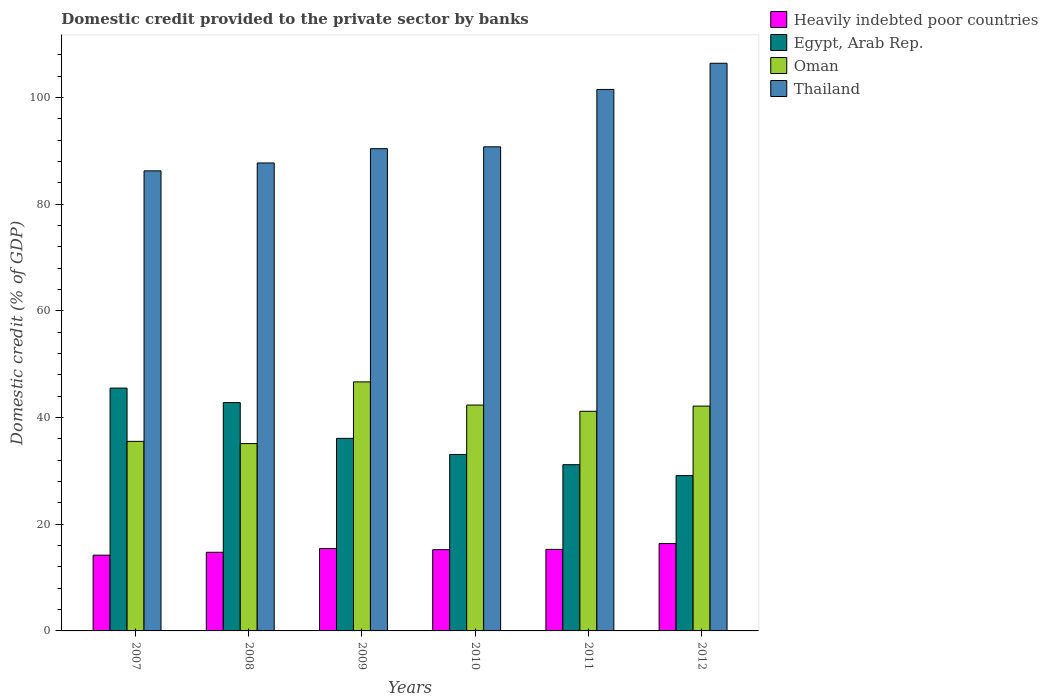How many different coloured bars are there?
Offer a very short reply. 4. How many bars are there on the 6th tick from the left?
Keep it short and to the point. 4. How many bars are there on the 6th tick from the right?
Keep it short and to the point. 4. What is the domestic credit provided to the private sector by banks in Oman in 2007?
Give a very brief answer. 35.53. Across all years, what is the maximum domestic credit provided to the private sector by banks in Thailand?
Provide a short and direct response. 106.4. Across all years, what is the minimum domestic credit provided to the private sector by banks in Thailand?
Offer a very short reply. 86.23. In which year was the domestic credit provided to the private sector by banks in Thailand maximum?
Provide a succinct answer. 2012. In which year was the domestic credit provided to the private sector by banks in Egypt, Arab Rep. minimum?
Provide a short and direct response. 2012. What is the total domestic credit provided to the private sector by banks in Oman in the graph?
Provide a succinct answer. 242.95. What is the difference between the domestic credit provided to the private sector by banks in Egypt, Arab Rep. in 2009 and that in 2012?
Make the answer very short. 6.98. What is the difference between the domestic credit provided to the private sector by banks in Egypt, Arab Rep. in 2009 and the domestic credit provided to the private sector by banks in Heavily indebted poor countries in 2012?
Ensure brevity in your answer.  19.72. What is the average domestic credit provided to the private sector by banks in Thailand per year?
Keep it short and to the point. 93.82. In the year 2010, what is the difference between the domestic credit provided to the private sector by banks in Egypt, Arab Rep. and domestic credit provided to the private sector by banks in Thailand?
Keep it short and to the point. -57.66. In how many years, is the domestic credit provided to the private sector by banks in Egypt, Arab Rep. greater than 40 %?
Ensure brevity in your answer.  2. What is the ratio of the domestic credit provided to the private sector by banks in Thailand in 2009 to that in 2011?
Make the answer very short. 0.89. Is the domestic credit provided to the private sector by banks in Oman in 2008 less than that in 2012?
Ensure brevity in your answer.  Yes. Is the difference between the domestic credit provided to the private sector by banks in Egypt, Arab Rep. in 2007 and 2012 greater than the difference between the domestic credit provided to the private sector by banks in Thailand in 2007 and 2012?
Your response must be concise. Yes. What is the difference between the highest and the second highest domestic credit provided to the private sector by banks in Egypt, Arab Rep.?
Offer a terse response. 2.72. What is the difference between the highest and the lowest domestic credit provided to the private sector by banks in Oman?
Give a very brief answer. 11.57. In how many years, is the domestic credit provided to the private sector by banks in Egypt, Arab Rep. greater than the average domestic credit provided to the private sector by banks in Egypt, Arab Rep. taken over all years?
Ensure brevity in your answer.  2. Is the sum of the domestic credit provided to the private sector by banks in Thailand in 2009 and 2012 greater than the maximum domestic credit provided to the private sector by banks in Egypt, Arab Rep. across all years?
Make the answer very short. Yes. Is it the case that in every year, the sum of the domestic credit provided to the private sector by banks in Thailand and domestic credit provided to the private sector by banks in Oman is greater than the sum of domestic credit provided to the private sector by banks in Heavily indebted poor countries and domestic credit provided to the private sector by banks in Egypt, Arab Rep.?
Make the answer very short. No. What does the 3rd bar from the left in 2012 represents?
Your answer should be very brief. Oman. What does the 4th bar from the right in 2012 represents?
Offer a terse response. Heavily indebted poor countries. Is it the case that in every year, the sum of the domestic credit provided to the private sector by banks in Egypt, Arab Rep. and domestic credit provided to the private sector by banks in Heavily indebted poor countries is greater than the domestic credit provided to the private sector by banks in Oman?
Give a very brief answer. Yes. Are all the bars in the graph horizontal?
Keep it short and to the point. No. How many years are there in the graph?
Keep it short and to the point. 6. Are the values on the major ticks of Y-axis written in scientific E-notation?
Ensure brevity in your answer.  No. Does the graph contain any zero values?
Provide a succinct answer. No. What is the title of the graph?
Provide a succinct answer. Domestic credit provided to the private sector by banks. What is the label or title of the Y-axis?
Provide a succinct answer. Domestic credit (% of GDP). What is the Domestic credit (% of GDP) of Heavily indebted poor countries in 2007?
Ensure brevity in your answer.  14.19. What is the Domestic credit (% of GDP) of Egypt, Arab Rep. in 2007?
Keep it short and to the point. 45.52. What is the Domestic credit (% of GDP) of Oman in 2007?
Keep it short and to the point. 35.53. What is the Domestic credit (% of GDP) in Thailand in 2007?
Provide a succinct answer. 86.23. What is the Domestic credit (% of GDP) in Heavily indebted poor countries in 2008?
Offer a very short reply. 14.74. What is the Domestic credit (% of GDP) of Egypt, Arab Rep. in 2008?
Offer a very short reply. 42.8. What is the Domestic credit (% of GDP) in Oman in 2008?
Provide a succinct answer. 35.11. What is the Domestic credit (% of GDP) of Thailand in 2008?
Your answer should be very brief. 87.71. What is the Domestic credit (% of GDP) in Heavily indebted poor countries in 2009?
Provide a short and direct response. 15.44. What is the Domestic credit (% of GDP) in Egypt, Arab Rep. in 2009?
Your response must be concise. 36.09. What is the Domestic credit (% of GDP) in Oman in 2009?
Your answer should be compact. 46.68. What is the Domestic credit (% of GDP) of Thailand in 2009?
Your response must be concise. 90.38. What is the Domestic credit (% of GDP) of Heavily indebted poor countries in 2010?
Offer a terse response. 15.23. What is the Domestic credit (% of GDP) in Egypt, Arab Rep. in 2010?
Ensure brevity in your answer.  33.07. What is the Domestic credit (% of GDP) of Oman in 2010?
Make the answer very short. 42.33. What is the Domestic credit (% of GDP) of Thailand in 2010?
Your answer should be very brief. 90.73. What is the Domestic credit (% of GDP) in Heavily indebted poor countries in 2011?
Make the answer very short. 15.28. What is the Domestic credit (% of GDP) in Egypt, Arab Rep. in 2011?
Offer a very short reply. 31.15. What is the Domestic credit (% of GDP) of Oman in 2011?
Offer a very short reply. 41.17. What is the Domestic credit (% of GDP) of Thailand in 2011?
Make the answer very short. 101.49. What is the Domestic credit (% of GDP) of Heavily indebted poor countries in 2012?
Your response must be concise. 16.37. What is the Domestic credit (% of GDP) in Egypt, Arab Rep. in 2012?
Provide a short and direct response. 29.11. What is the Domestic credit (% of GDP) of Oman in 2012?
Your answer should be very brief. 42.14. What is the Domestic credit (% of GDP) of Thailand in 2012?
Ensure brevity in your answer.  106.4. Across all years, what is the maximum Domestic credit (% of GDP) in Heavily indebted poor countries?
Your answer should be very brief. 16.37. Across all years, what is the maximum Domestic credit (% of GDP) in Egypt, Arab Rep.?
Provide a succinct answer. 45.52. Across all years, what is the maximum Domestic credit (% of GDP) in Oman?
Provide a succinct answer. 46.68. Across all years, what is the maximum Domestic credit (% of GDP) of Thailand?
Keep it short and to the point. 106.4. Across all years, what is the minimum Domestic credit (% of GDP) of Heavily indebted poor countries?
Ensure brevity in your answer.  14.19. Across all years, what is the minimum Domestic credit (% of GDP) of Egypt, Arab Rep.?
Provide a short and direct response. 29.11. Across all years, what is the minimum Domestic credit (% of GDP) of Oman?
Your answer should be very brief. 35.11. Across all years, what is the minimum Domestic credit (% of GDP) in Thailand?
Your answer should be very brief. 86.23. What is the total Domestic credit (% of GDP) of Heavily indebted poor countries in the graph?
Provide a short and direct response. 91.26. What is the total Domestic credit (% of GDP) of Egypt, Arab Rep. in the graph?
Give a very brief answer. 217.75. What is the total Domestic credit (% of GDP) in Oman in the graph?
Make the answer very short. 242.95. What is the total Domestic credit (% of GDP) of Thailand in the graph?
Provide a short and direct response. 562.93. What is the difference between the Domestic credit (% of GDP) in Heavily indebted poor countries in 2007 and that in 2008?
Offer a very short reply. -0.55. What is the difference between the Domestic credit (% of GDP) of Egypt, Arab Rep. in 2007 and that in 2008?
Offer a terse response. 2.72. What is the difference between the Domestic credit (% of GDP) of Oman in 2007 and that in 2008?
Offer a very short reply. 0.42. What is the difference between the Domestic credit (% of GDP) in Thailand in 2007 and that in 2008?
Your answer should be very brief. -1.48. What is the difference between the Domestic credit (% of GDP) of Heavily indebted poor countries in 2007 and that in 2009?
Offer a terse response. -1.25. What is the difference between the Domestic credit (% of GDP) of Egypt, Arab Rep. in 2007 and that in 2009?
Your answer should be compact. 9.42. What is the difference between the Domestic credit (% of GDP) of Oman in 2007 and that in 2009?
Your answer should be very brief. -11.15. What is the difference between the Domestic credit (% of GDP) in Thailand in 2007 and that in 2009?
Offer a terse response. -4.16. What is the difference between the Domestic credit (% of GDP) in Heavily indebted poor countries in 2007 and that in 2010?
Your answer should be very brief. -1.03. What is the difference between the Domestic credit (% of GDP) in Egypt, Arab Rep. in 2007 and that in 2010?
Give a very brief answer. 12.44. What is the difference between the Domestic credit (% of GDP) of Oman in 2007 and that in 2010?
Provide a succinct answer. -6.81. What is the difference between the Domestic credit (% of GDP) in Thailand in 2007 and that in 2010?
Offer a very short reply. -4.5. What is the difference between the Domestic credit (% of GDP) in Heavily indebted poor countries in 2007 and that in 2011?
Your answer should be compact. -1.09. What is the difference between the Domestic credit (% of GDP) of Egypt, Arab Rep. in 2007 and that in 2011?
Keep it short and to the point. 14.36. What is the difference between the Domestic credit (% of GDP) of Oman in 2007 and that in 2011?
Make the answer very short. -5.64. What is the difference between the Domestic credit (% of GDP) of Thailand in 2007 and that in 2011?
Give a very brief answer. -15.26. What is the difference between the Domestic credit (% of GDP) in Heavily indebted poor countries in 2007 and that in 2012?
Provide a short and direct response. -2.18. What is the difference between the Domestic credit (% of GDP) of Egypt, Arab Rep. in 2007 and that in 2012?
Provide a succinct answer. 16.4. What is the difference between the Domestic credit (% of GDP) of Oman in 2007 and that in 2012?
Offer a terse response. -6.61. What is the difference between the Domestic credit (% of GDP) in Thailand in 2007 and that in 2012?
Keep it short and to the point. -20.17. What is the difference between the Domestic credit (% of GDP) of Heavily indebted poor countries in 2008 and that in 2009?
Provide a succinct answer. -0.7. What is the difference between the Domestic credit (% of GDP) of Egypt, Arab Rep. in 2008 and that in 2009?
Provide a short and direct response. 6.7. What is the difference between the Domestic credit (% of GDP) in Oman in 2008 and that in 2009?
Give a very brief answer. -11.57. What is the difference between the Domestic credit (% of GDP) in Thailand in 2008 and that in 2009?
Provide a short and direct response. -2.68. What is the difference between the Domestic credit (% of GDP) of Heavily indebted poor countries in 2008 and that in 2010?
Offer a very short reply. -0.48. What is the difference between the Domestic credit (% of GDP) in Egypt, Arab Rep. in 2008 and that in 2010?
Offer a very short reply. 9.73. What is the difference between the Domestic credit (% of GDP) in Oman in 2008 and that in 2010?
Keep it short and to the point. -7.23. What is the difference between the Domestic credit (% of GDP) in Thailand in 2008 and that in 2010?
Make the answer very short. -3.02. What is the difference between the Domestic credit (% of GDP) in Heavily indebted poor countries in 2008 and that in 2011?
Keep it short and to the point. -0.54. What is the difference between the Domestic credit (% of GDP) of Egypt, Arab Rep. in 2008 and that in 2011?
Your answer should be compact. 11.64. What is the difference between the Domestic credit (% of GDP) of Oman in 2008 and that in 2011?
Offer a very short reply. -6.06. What is the difference between the Domestic credit (% of GDP) in Thailand in 2008 and that in 2011?
Provide a succinct answer. -13.78. What is the difference between the Domestic credit (% of GDP) in Heavily indebted poor countries in 2008 and that in 2012?
Make the answer very short. -1.63. What is the difference between the Domestic credit (% of GDP) of Egypt, Arab Rep. in 2008 and that in 2012?
Offer a terse response. 13.68. What is the difference between the Domestic credit (% of GDP) of Oman in 2008 and that in 2012?
Offer a very short reply. -7.03. What is the difference between the Domestic credit (% of GDP) in Thailand in 2008 and that in 2012?
Your answer should be very brief. -18.69. What is the difference between the Domestic credit (% of GDP) of Heavily indebted poor countries in 2009 and that in 2010?
Your response must be concise. 0.22. What is the difference between the Domestic credit (% of GDP) of Egypt, Arab Rep. in 2009 and that in 2010?
Your answer should be very brief. 3.02. What is the difference between the Domestic credit (% of GDP) in Oman in 2009 and that in 2010?
Ensure brevity in your answer.  4.34. What is the difference between the Domestic credit (% of GDP) of Thailand in 2009 and that in 2010?
Provide a short and direct response. -0.35. What is the difference between the Domestic credit (% of GDP) of Heavily indebted poor countries in 2009 and that in 2011?
Ensure brevity in your answer.  0.16. What is the difference between the Domestic credit (% of GDP) of Egypt, Arab Rep. in 2009 and that in 2011?
Make the answer very short. 4.94. What is the difference between the Domestic credit (% of GDP) of Oman in 2009 and that in 2011?
Keep it short and to the point. 5.51. What is the difference between the Domestic credit (% of GDP) in Thailand in 2009 and that in 2011?
Your response must be concise. -11.1. What is the difference between the Domestic credit (% of GDP) in Heavily indebted poor countries in 2009 and that in 2012?
Your response must be concise. -0.93. What is the difference between the Domestic credit (% of GDP) of Egypt, Arab Rep. in 2009 and that in 2012?
Keep it short and to the point. 6.98. What is the difference between the Domestic credit (% of GDP) of Oman in 2009 and that in 2012?
Your answer should be compact. 4.54. What is the difference between the Domestic credit (% of GDP) in Thailand in 2009 and that in 2012?
Provide a succinct answer. -16.01. What is the difference between the Domestic credit (% of GDP) of Heavily indebted poor countries in 2010 and that in 2011?
Make the answer very short. -0.06. What is the difference between the Domestic credit (% of GDP) in Egypt, Arab Rep. in 2010 and that in 2011?
Provide a succinct answer. 1.92. What is the difference between the Domestic credit (% of GDP) of Oman in 2010 and that in 2011?
Make the answer very short. 1.17. What is the difference between the Domestic credit (% of GDP) in Thailand in 2010 and that in 2011?
Make the answer very short. -10.76. What is the difference between the Domestic credit (% of GDP) of Heavily indebted poor countries in 2010 and that in 2012?
Your answer should be very brief. -1.15. What is the difference between the Domestic credit (% of GDP) in Egypt, Arab Rep. in 2010 and that in 2012?
Ensure brevity in your answer.  3.96. What is the difference between the Domestic credit (% of GDP) in Oman in 2010 and that in 2012?
Ensure brevity in your answer.  0.19. What is the difference between the Domestic credit (% of GDP) in Thailand in 2010 and that in 2012?
Ensure brevity in your answer.  -15.66. What is the difference between the Domestic credit (% of GDP) of Heavily indebted poor countries in 2011 and that in 2012?
Offer a very short reply. -1.09. What is the difference between the Domestic credit (% of GDP) in Egypt, Arab Rep. in 2011 and that in 2012?
Offer a terse response. 2.04. What is the difference between the Domestic credit (% of GDP) in Oman in 2011 and that in 2012?
Make the answer very short. -0.97. What is the difference between the Domestic credit (% of GDP) in Thailand in 2011 and that in 2012?
Offer a very short reply. -4.91. What is the difference between the Domestic credit (% of GDP) of Heavily indebted poor countries in 2007 and the Domestic credit (% of GDP) of Egypt, Arab Rep. in 2008?
Keep it short and to the point. -28.6. What is the difference between the Domestic credit (% of GDP) in Heavily indebted poor countries in 2007 and the Domestic credit (% of GDP) in Oman in 2008?
Provide a succinct answer. -20.91. What is the difference between the Domestic credit (% of GDP) in Heavily indebted poor countries in 2007 and the Domestic credit (% of GDP) in Thailand in 2008?
Your answer should be compact. -73.51. What is the difference between the Domestic credit (% of GDP) of Egypt, Arab Rep. in 2007 and the Domestic credit (% of GDP) of Oman in 2008?
Provide a short and direct response. 10.41. What is the difference between the Domestic credit (% of GDP) in Egypt, Arab Rep. in 2007 and the Domestic credit (% of GDP) in Thailand in 2008?
Provide a short and direct response. -42.19. What is the difference between the Domestic credit (% of GDP) in Oman in 2007 and the Domestic credit (% of GDP) in Thailand in 2008?
Offer a terse response. -52.18. What is the difference between the Domestic credit (% of GDP) of Heavily indebted poor countries in 2007 and the Domestic credit (% of GDP) of Egypt, Arab Rep. in 2009?
Provide a succinct answer. -21.9. What is the difference between the Domestic credit (% of GDP) in Heavily indebted poor countries in 2007 and the Domestic credit (% of GDP) in Oman in 2009?
Provide a short and direct response. -32.48. What is the difference between the Domestic credit (% of GDP) in Heavily indebted poor countries in 2007 and the Domestic credit (% of GDP) in Thailand in 2009?
Ensure brevity in your answer.  -76.19. What is the difference between the Domestic credit (% of GDP) of Egypt, Arab Rep. in 2007 and the Domestic credit (% of GDP) of Oman in 2009?
Offer a terse response. -1.16. What is the difference between the Domestic credit (% of GDP) in Egypt, Arab Rep. in 2007 and the Domestic credit (% of GDP) in Thailand in 2009?
Make the answer very short. -44.87. What is the difference between the Domestic credit (% of GDP) of Oman in 2007 and the Domestic credit (% of GDP) of Thailand in 2009?
Give a very brief answer. -54.86. What is the difference between the Domestic credit (% of GDP) of Heavily indebted poor countries in 2007 and the Domestic credit (% of GDP) of Egypt, Arab Rep. in 2010?
Ensure brevity in your answer.  -18.88. What is the difference between the Domestic credit (% of GDP) of Heavily indebted poor countries in 2007 and the Domestic credit (% of GDP) of Oman in 2010?
Ensure brevity in your answer.  -28.14. What is the difference between the Domestic credit (% of GDP) of Heavily indebted poor countries in 2007 and the Domestic credit (% of GDP) of Thailand in 2010?
Give a very brief answer. -76.54. What is the difference between the Domestic credit (% of GDP) of Egypt, Arab Rep. in 2007 and the Domestic credit (% of GDP) of Oman in 2010?
Make the answer very short. 3.18. What is the difference between the Domestic credit (% of GDP) in Egypt, Arab Rep. in 2007 and the Domestic credit (% of GDP) in Thailand in 2010?
Provide a short and direct response. -45.22. What is the difference between the Domestic credit (% of GDP) of Oman in 2007 and the Domestic credit (% of GDP) of Thailand in 2010?
Make the answer very short. -55.2. What is the difference between the Domestic credit (% of GDP) in Heavily indebted poor countries in 2007 and the Domestic credit (% of GDP) in Egypt, Arab Rep. in 2011?
Keep it short and to the point. -16.96. What is the difference between the Domestic credit (% of GDP) of Heavily indebted poor countries in 2007 and the Domestic credit (% of GDP) of Oman in 2011?
Offer a very short reply. -26.97. What is the difference between the Domestic credit (% of GDP) of Heavily indebted poor countries in 2007 and the Domestic credit (% of GDP) of Thailand in 2011?
Give a very brief answer. -87.29. What is the difference between the Domestic credit (% of GDP) in Egypt, Arab Rep. in 2007 and the Domestic credit (% of GDP) in Oman in 2011?
Offer a terse response. 4.35. What is the difference between the Domestic credit (% of GDP) in Egypt, Arab Rep. in 2007 and the Domestic credit (% of GDP) in Thailand in 2011?
Your answer should be compact. -55.97. What is the difference between the Domestic credit (% of GDP) in Oman in 2007 and the Domestic credit (% of GDP) in Thailand in 2011?
Offer a very short reply. -65.96. What is the difference between the Domestic credit (% of GDP) of Heavily indebted poor countries in 2007 and the Domestic credit (% of GDP) of Egypt, Arab Rep. in 2012?
Your answer should be compact. -14.92. What is the difference between the Domestic credit (% of GDP) in Heavily indebted poor countries in 2007 and the Domestic credit (% of GDP) in Oman in 2012?
Give a very brief answer. -27.95. What is the difference between the Domestic credit (% of GDP) of Heavily indebted poor countries in 2007 and the Domestic credit (% of GDP) of Thailand in 2012?
Provide a short and direct response. -92.2. What is the difference between the Domestic credit (% of GDP) in Egypt, Arab Rep. in 2007 and the Domestic credit (% of GDP) in Oman in 2012?
Ensure brevity in your answer.  3.37. What is the difference between the Domestic credit (% of GDP) of Egypt, Arab Rep. in 2007 and the Domestic credit (% of GDP) of Thailand in 2012?
Keep it short and to the point. -60.88. What is the difference between the Domestic credit (% of GDP) of Oman in 2007 and the Domestic credit (% of GDP) of Thailand in 2012?
Provide a short and direct response. -70.87. What is the difference between the Domestic credit (% of GDP) in Heavily indebted poor countries in 2008 and the Domestic credit (% of GDP) in Egypt, Arab Rep. in 2009?
Your response must be concise. -21.35. What is the difference between the Domestic credit (% of GDP) of Heavily indebted poor countries in 2008 and the Domestic credit (% of GDP) of Oman in 2009?
Offer a terse response. -31.94. What is the difference between the Domestic credit (% of GDP) in Heavily indebted poor countries in 2008 and the Domestic credit (% of GDP) in Thailand in 2009?
Offer a very short reply. -75.64. What is the difference between the Domestic credit (% of GDP) in Egypt, Arab Rep. in 2008 and the Domestic credit (% of GDP) in Oman in 2009?
Offer a very short reply. -3.88. What is the difference between the Domestic credit (% of GDP) of Egypt, Arab Rep. in 2008 and the Domestic credit (% of GDP) of Thailand in 2009?
Give a very brief answer. -47.59. What is the difference between the Domestic credit (% of GDP) in Oman in 2008 and the Domestic credit (% of GDP) in Thailand in 2009?
Provide a short and direct response. -55.28. What is the difference between the Domestic credit (% of GDP) of Heavily indebted poor countries in 2008 and the Domestic credit (% of GDP) of Egypt, Arab Rep. in 2010?
Offer a very short reply. -18.33. What is the difference between the Domestic credit (% of GDP) in Heavily indebted poor countries in 2008 and the Domestic credit (% of GDP) in Oman in 2010?
Your answer should be compact. -27.59. What is the difference between the Domestic credit (% of GDP) in Heavily indebted poor countries in 2008 and the Domestic credit (% of GDP) in Thailand in 2010?
Ensure brevity in your answer.  -75.99. What is the difference between the Domestic credit (% of GDP) of Egypt, Arab Rep. in 2008 and the Domestic credit (% of GDP) of Oman in 2010?
Provide a short and direct response. 0.46. What is the difference between the Domestic credit (% of GDP) of Egypt, Arab Rep. in 2008 and the Domestic credit (% of GDP) of Thailand in 2010?
Your answer should be compact. -47.93. What is the difference between the Domestic credit (% of GDP) of Oman in 2008 and the Domestic credit (% of GDP) of Thailand in 2010?
Provide a short and direct response. -55.62. What is the difference between the Domestic credit (% of GDP) of Heavily indebted poor countries in 2008 and the Domestic credit (% of GDP) of Egypt, Arab Rep. in 2011?
Your answer should be compact. -16.41. What is the difference between the Domestic credit (% of GDP) of Heavily indebted poor countries in 2008 and the Domestic credit (% of GDP) of Oman in 2011?
Make the answer very short. -26.43. What is the difference between the Domestic credit (% of GDP) of Heavily indebted poor countries in 2008 and the Domestic credit (% of GDP) of Thailand in 2011?
Ensure brevity in your answer.  -86.75. What is the difference between the Domestic credit (% of GDP) of Egypt, Arab Rep. in 2008 and the Domestic credit (% of GDP) of Oman in 2011?
Offer a terse response. 1.63. What is the difference between the Domestic credit (% of GDP) in Egypt, Arab Rep. in 2008 and the Domestic credit (% of GDP) in Thailand in 2011?
Provide a succinct answer. -58.69. What is the difference between the Domestic credit (% of GDP) in Oman in 2008 and the Domestic credit (% of GDP) in Thailand in 2011?
Your answer should be very brief. -66.38. What is the difference between the Domestic credit (% of GDP) of Heavily indebted poor countries in 2008 and the Domestic credit (% of GDP) of Egypt, Arab Rep. in 2012?
Your answer should be very brief. -14.37. What is the difference between the Domestic credit (% of GDP) of Heavily indebted poor countries in 2008 and the Domestic credit (% of GDP) of Oman in 2012?
Your answer should be compact. -27.4. What is the difference between the Domestic credit (% of GDP) in Heavily indebted poor countries in 2008 and the Domestic credit (% of GDP) in Thailand in 2012?
Keep it short and to the point. -91.65. What is the difference between the Domestic credit (% of GDP) in Egypt, Arab Rep. in 2008 and the Domestic credit (% of GDP) in Oman in 2012?
Offer a terse response. 0.66. What is the difference between the Domestic credit (% of GDP) in Egypt, Arab Rep. in 2008 and the Domestic credit (% of GDP) in Thailand in 2012?
Your response must be concise. -63.6. What is the difference between the Domestic credit (% of GDP) of Oman in 2008 and the Domestic credit (% of GDP) of Thailand in 2012?
Give a very brief answer. -71.29. What is the difference between the Domestic credit (% of GDP) of Heavily indebted poor countries in 2009 and the Domestic credit (% of GDP) of Egypt, Arab Rep. in 2010?
Provide a short and direct response. -17.63. What is the difference between the Domestic credit (% of GDP) in Heavily indebted poor countries in 2009 and the Domestic credit (% of GDP) in Oman in 2010?
Ensure brevity in your answer.  -26.89. What is the difference between the Domestic credit (% of GDP) in Heavily indebted poor countries in 2009 and the Domestic credit (% of GDP) in Thailand in 2010?
Provide a short and direct response. -75.29. What is the difference between the Domestic credit (% of GDP) in Egypt, Arab Rep. in 2009 and the Domestic credit (% of GDP) in Oman in 2010?
Ensure brevity in your answer.  -6.24. What is the difference between the Domestic credit (% of GDP) of Egypt, Arab Rep. in 2009 and the Domestic credit (% of GDP) of Thailand in 2010?
Provide a short and direct response. -54.64. What is the difference between the Domestic credit (% of GDP) in Oman in 2009 and the Domestic credit (% of GDP) in Thailand in 2010?
Offer a very short reply. -44.05. What is the difference between the Domestic credit (% of GDP) of Heavily indebted poor countries in 2009 and the Domestic credit (% of GDP) of Egypt, Arab Rep. in 2011?
Make the answer very short. -15.71. What is the difference between the Domestic credit (% of GDP) of Heavily indebted poor countries in 2009 and the Domestic credit (% of GDP) of Oman in 2011?
Give a very brief answer. -25.73. What is the difference between the Domestic credit (% of GDP) of Heavily indebted poor countries in 2009 and the Domestic credit (% of GDP) of Thailand in 2011?
Provide a short and direct response. -86.05. What is the difference between the Domestic credit (% of GDP) of Egypt, Arab Rep. in 2009 and the Domestic credit (% of GDP) of Oman in 2011?
Make the answer very short. -5.07. What is the difference between the Domestic credit (% of GDP) of Egypt, Arab Rep. in 2009 and the Domestic credit (% of GDP) of Thailand in 2011?
Your answer should be very brief. -65.39. What is the difference between the Domestic credit (% of GDP) in Oman in 2009 and the Domestic credit (% of GDP) in Thailand in 2011?
Offer a terse response. -54.81. What is the difference between the Domestic credit (% of GDP) in Heavily indebted poor countries in 2009 and the Domestic credit (% of GDP) in Egypt, Arab Rep. in 2012?
Make the answer very short. -13.67. What is the difference between the Domestic credit (% of GDP) of Heavily indebted poor countries in 2009 and the Domestic credit (% of GDP) of Oman in 2012?
Make the answer very short. -26.7. What is the difference between the Domestic credit (% of GDP) in Heavily indebted poor countries in 2009 and the Domestic credit (% of GDP) in Thailand in 2012?
Offer a terse response. -90.95. What is the difference between the Domestic credit (% of GDP) of Egypt, Arab Rep. in 2009 and the Domestic credit (% of GDP) of Oman in 2012?
Your answer should be very brief. -6.05. What is the difference between the Domestic credit (% of GDP) of Egypt, Arab Rep. in 2009 and the Domestic credit (% of GDP) of Thailand in 2012?
Your answer should be very brief. -70.3. What is the difference between the Domestic credit (% of GDP) of Oman in 2009 and the Domestic credit (% of GDP) of Thailand in 2012?
Make the answer very short. -59.72. What is the difference between the Domestic credit (% of GDP) in Heavily indebted poor countries in 2010 and the Domestic credit (% of GDP) in Egypt, Arab Rep. in 2011?
Ensure brevity in your answer.  -15.93. What is the difference between the Domestic credit (% of GDP) of Heavily indebted poor countries in 2010 and the Domestic credit (% of GDP) of Oman in 2011?
Give a very brief answer. -25.94. What is the difference between the Domestic credit (% of GDP) of Heavily indebted poor countries in 2010 and the Domestic credit (% of GDP) of Thailand in 2011?
Your response must be concise. -86.26. What is the difference between the Domestic credit (% of GDP) of Egypt, Arab Rep. in 2010 and the Domestic credit (% of GDP) of Oman in 2011?
Provide a short and direct response. -8.09. What is the difference between the Domestic credit (% of GDP) in Egypt, Arab Rep. in 2010 and the Domestic credit (% of GDP) in Thailand in 2011?
Give a very brief answer. -68.41. What is the difference between the Domestic credit (% of GDP) of Oman in 2010 and the Domestic credit (% of GDP) of Thailand in 2011?
Keep it short and to the point. -59.15. What is the difference between the Domestic credit (% of GDP) in Heavily indebted poor countries in 2010 and the Domestic credit (% of GDP) in Egypt, Arab Rep. in 2012?
Make the answer very short. -13.89. What is the difference between the Domestic credit (% of GDP) in Heavily indebted poor countries in 2010 and the Domestic credit (% of GDP) in Oman in 2012?
Keep it short and to the point. -26.92. What is the difference between the Domestic credit (% of GDP) of Heavily indebted poor countries in 2010 and the Domestic credit (% of GDP) of Thailand in 2012?
Ensure brevity in your answer.  -91.17. What is the difference between the Domestic credit (% of GDP) in Egypt, Arab Rep. in 2010 and the Domestic credit (% of GDP) in Oman in 2012?
Make the answer very short. -9.07. What is the difference between the Domestic credit (% of GDP) in Egypt, Arab Rep. in 2010 and the Domestic credit (% of GDP) in Thailand in 2012?
Offer a terse response. -73.32. What is the difference between the Domestic credit (% of GDP) of Oman in 2010 and the Domestic credit (% of GDP) of Thailand in 2012?
Provide a succinct answer. -64.06. What is the difference between the Domestic credit (% of GDP) of Heavily indebted poor countries in 2011 and the Domestic credit (% of GDP) of Egypt, Arab Rep. in 2012?
Provide a short and direct response. -13.83. What is the difference between the Domestic credit (% of GDP) of Heavily indebted poor countries in 2011 and the Domestic credit (% of GDP) of Oman in 2012?
Provide a short and direct response. -26.86. What is the difference between the Domestic credit (% of GDP) of Heavily indebted poor countries in 2011 and the Domestic credit (% of GDP) of Thailand in 2012?
Give a very brief answer. -91.11. What is the difference between the Domestic credit (% of GDP) in Egypt, Arab Rep. in 2011 and the Domestic credit (% of GDP) in Oman in 2012?
Make the answer very short. -10.99. What is the difference between the Domestic credit (% of GDP) in Egypt, Arab Rep. in 2011 and the Domestic credit (% of GDP) in Thailand in 2012?
Offer a terse response. -75.24. What is the difference between the Domestic credit (% of GDP) of Oman in 2011 and the Domestic credit (% of GDP) of Thailand in 2012?
Give a very brief answer. -65.23. What is the average Domestic credit (% of GDP) of Heavily indebted poor countries per year?
Your response must be concise. 15.21. What is the average Domestic credit (% of GDP) in Egypt, Arab Rep. per year?
Your answer should be very brief. 36.29. What is the average Domestic credit (% of GDP) of Oman per year?
Provide a succinct answer. 40.49. What is the average Domestic credit (% of GDP) of Thailand per year?
Your answer should be compact. 93.82. In the year 2007, what is the difference between the Domestic credit (% of GDP) in Heavily indebted poor countries and Domestic credit (% of GDP) in Egypt, Arab Rep.?
Ensure brevity in your answer.  -31.32. In the year 2007, what is the difference between the Domestic credit (% of GDP) of Heavily indebted poor countries and Domestic credit (% of GDP) of Oman?
Keep it short and to the point. -21.33. In the year 2007, what is the difference between the Domestic credit (% of GDP) in Heavily indebted poor countries and Domestic credit (% of GDP) in Thailand?
Provide a succinct answer. -72.03. In the year 2007, what is the difference between the Domestic credit (% of GDP) of Egypt, Arab Rep. and Domestic credit (% of GDP) of Oman?
Give a very brief answer. 9.99. In the year 2007, what is the difference between the Domestic credit (% of GDP) of Egypt, Arab Rep. and Domestic credit (% of GDP) of Thailand?
Ensure brevity in your answer.  -40.71. In the year 2007, what is the difference between the Domestic credit (% of GDP) in Oman and Domestic credit (% of GDP) in Thailand?
Give a very brief answer. -50.7. In the year 2008, what is the difference between the Domestic credit (% of GDP) in Heavily indebted poor countries and Domestic credit (% of GDP) in Egypt, Arab Rep.?
Ensure brevity in your answer.  -28.06. In the year 2008, what is the difference between the Domestic credit (% of GDP) of Heavily indebted poor countries and Domestic credit (% of GDP) of Oman?
Offer a terse response. -20.37. In the year 2008, what is the difference between the Domestic credit (% of GDP) of Heavily indebted poor countries and Domestic credit (% of GDP) of Thailand?
Your answer should be very brief. -72.97. In the year 2008, what is the difference between the Domestic credit (% of GDP) of Egypt, Arab Rep. and Domestic credit (% of GDP) of Oman?
Offer a terse response. 7.69. In the year 2008, what is the difference between the Domestic credit (% of GDP) of Egypt, Arab Rep. and Domestic credit (% of GDP) of Thailand?
Your response must be concise. -44.91. In the year 2008, what is the difference between the Domestic credit (% of GDP) of Oman and Domestic credit (% of GDP) of Thailand?
Keep it short and to the point. -52.6. In the year 2009, what is the difference between the Domestic credit (% of GDP) of Heavily indebted poor countries and Domestic credit (% of GDP) of Egypt, Arab Rep.?
Provide a short and direct response. -20.65. In the year 2009, what is the difference between the Domestic credit (% of GDP) in Heavily indebted poor countries and Domestic credit (% of GDP) in Oman?
Your answer should be compact. -31.24. In the year 2009, what is the difference between the Domestic credit (% of GDP) in Heavily indebted poor countries and Domestic credit (% of GDP) in Thailand?
Provide a succinct answer. -74.94. In the year 2009, what is the difference between the Domestic credit (% of GDP) in Egypt, Arab Rep. and Domestic credit (% of GDP) in Oman?
Provide a short and direct response. -10.58. In the year 2009, what is the difference between the Domestic credit (% of GDP) of Egypt, Arab Rep. and Domestic credit (% of GDP) of Thailand?
Give a very brief answer. -54.29. In the year 2009, what is the difference between the Domestic credit (% of GDP) in Oman and Domestic credit (% of GDP) in Thailand?
Provide a succinct answer. -43.71. In the year 2010, what is the difference between the Domestic credit (% of GDP) in Heavily indebted poor countries and Domestic credit (% of GDP) in Egypt, Arab Rep.?
Make the answer very short. -17.85. In the year 2010, what is the difference between the Domestic credit (% of GDP) in Heavily indebted poor countries and Domestic credit (% of GDP) in Oman?
Your answer should be very brief. -27.11. In the year 2010, what is the difference between the Domestic credit (% of GDP) of Heavily indebted poor countries and Domestic credit (% of GDP) of Thailand?
Offer a very short reply. -75.51. In the year 2010, what is the difference between the Domestic credit (% of GDP) in Egypt, Arab Rep. and Domestic credit (% of GDP) in Oman?
Offer a terse response. -9.26. In the year 2010, what is the difference between the Domestic credit (% of GDP) in Egypt, Arab Rep. and Domestic credit (% of GDP) in Thailand?
Offer a terse response. -57.66. In the year 2010, what is the difference between the Domestic credit (% of GDP) in Oman and Domestic credit (% of GDP) in Thailand?
Your answer should be very brief. -48.4. In the year 2011, what is the difference between the Domestic credit (% of GDP) of Heavily indebted poor countries and Domestic credit (% of GDP) of Egypt, Arab Rep.?
Your answer should be very brief. -15.87. In the year 2011, what is the difference between the Domestic credit (% of GDP) in Heavily indebted poor countries and Domestic credit (% of GDP) in Oman?
Make the answer very short. -25.88. In the year 2011, what is the difference between the Domestic credit (% of GDP) of Heavily indebted poor countries and Domestic credit (% of GDP) of Thailand?
Provide a short and direct response. -86.21. In the year 2011, what is the difference between the Domestic credit (% of GDP) in Egypt, Arab Rep. and Domestic credit (% of GDP) in Oman?
Ensure brevity in your answer.  -10.01. In the year 2011, what is the difference between the Domestic credit (% of GDP) of Egypt, Arab Rep. and Domestic credit (% of GDP) of Thailand?
Offer a terse response. -70.33. In the year 2011, what is the difference between the Domestic credit (% of GDP) in Oman and Domestic credit (% of GDP) in Thailand?
Offer a very short reply. -60.32. In the year 2012, what is the difference between the Domestic credit (% of GDP) of Heavily indebted poor countries and Domestic credit (% of GDP) of Egypt, Arab Rep.?
Make the answer very short. -12.74. In the year 2012, what is the difference between the Domestic credit (% of GDP) of Heavily indebted poor countries and Domestic credit (% of GDP) of Oman?
Give a very brief answer. -25.77. In the year 2012, what is the difference between the Domestic credit (% of GDP) of Heavily indebted poor countries and Domestic credit (% of GDP) of Thailand?
Keep it short and to the point. -90.02. In the year 2012, what is the difference between the Domestic credit (% of GDP) in Egypt, Arab Rep. and Domestic credit (% of GDP) in Oman?
Ensure brevity in your answer.  -13.03. In the year 2012, what is the difference between the Domestic credit (% of GDP) of Egypt, Arab Rep. and Domestic credit (% of GDP) of Thailand?
Your answer should be very brief. -77.28. In the year 2012, what is the difference between the Domestic credit (% of GDP) of Oman and Domestic credit (% of GDP) of Thailand?
Keep it short and to the point. -64.25. What is the ratio of the Domestic credit (% of GDP) of Heavily indebted poor countries in 2007 to that in 2008?
Provide a succinct answer. 0.96. What is the ratio of the Domestic credit (% of GDP) in Egypt, Arab Rep. in 2007 to that in 2008?
Provide a succinct answer. 1.06. What is the ratio of the Domestic credit (% of GDP) in Oman in 2007 to that in 2008?
Your answer should be compact. 1.01. What is the ratio of the Domestic credit (% of GDP) of Thailand in 2007 to that in 2008?
Your answer should be very brief. 0.98. What is the ratio of the Domestic credit (% of GDP) in Heavily indebted poor countries in 2007 to that in 2009?
Offer a very short reply. 0.92. What is the ratio of the Domestic credit (% of GDP) of Egypt, Arab Rep. in 2007 to that in 2009?
Ensure brevity in your answer.  1.26. What is the ratio of the Domestic credit (% of GDP) in Oman in 2007 to that in 2009?
Provide a succinct answer. 0.76. What is the ratio of the Domestic credit (% of GDP) of Thailand in 2007 to that in 2009?
Your answer should be very brief. 0.95. What is the ratio of the Domestic credit (% of GDP) of Heavily indebted poor countries in 2007 to that in 2010?
Your answer should be compact. 0.93. What is the ratio of the Domestic credit (% of GDP) in Egypt, Arab Rep. in 2007 to that in 2010?
Your response must be concise. 1.38. What is the ratio of the Domestic credit (% of GDP) of Oman in 2007 to that in 2010?
Keep it short and to the point. 0.84. What is the ratio of the Domestic credit (% of GDP) of Thailand in 2007 to that in 2010?
Your response must be concise. 0.95. What is the ratio of the Domestic credit (% of GDP) of Heavily indebted poor countries in 2007 to that in 2011?
Ensure brevity in your answer.  0.93. What is the ratio of the Domestic credit (% of GDP) of Egypt, Arab Rep. in 2007 to that in 2011?
Provide a short and direct response. 1.46. What is the ratio of the Domestic credit (% of GDP) in Oman in 2007 to that in 2011?
Offer a terse response. 0.86. What is the ratio of the Domestic credit (% of GDP) in Thailand in 2007 to that in 2011?
Give a very brief answer. 0.85. What is the ratio of the Domestic credit (% of GDP) in Heavily indebted poor countries in 2007 to that in 2012?
Give a very brief answer. 0.87. What is the ratio of the Domestic credit (% of GDP) in Egypt, Arab Rep. in 2007 to that in 2012?
Provide a succinct answer. 1.56. What is the ratio of the Domestic credit (% of GDP) of Oman in 2007 to that in 2012?
Give a very brief answer. 0.84. What is the ratio of the Domestic credit (% of GDP) of Thailand in 2007 to that in 2012?
Your answer should be very brief. 0.81. What is the ratio of the Domestic credit (% of GDP) in Heavily indebted poor countries in 2008 to that in 2009?
Ensure brevity in your answer.  0.95. What is the ratio of the Domestic credit (% of GDP) of Egypt, Arab Rep. in 2008 to that in 2009?
Keep it short and to the point. 1.19. What is the ratio of the Domestic credit (% of GDP) of Oman in 2008 to that in 2009?
Make the answer very short. 0.75. What is the ratio of the Domestic credit (% of GDP) of Thailand in 2008 to that in 2009?
Your response must be concise. 0.97. What is the ratio of the Domestic credit (% of GDP) in Heavily indebted poor countries in 2008 to that in 2010?
Provide a succinct answer. 0.97. What is the ratio of the Domestic credit (% of GDP) of Egypt, Arab Rep. in 2008 to that in 2010?
Your response must be concise. 1.29. What is the ratio of the Domestic credit (% of GDP) of Oman in 2008 to that in 2010?
Provide a short and direct response. 0.83. What is the ratio of the Domestic credit (% of GDP) in Thailand in 2008 to that in 2010?
Your response must be concise. 0.97. What is the ratio of the Domestic credit (% of GDP) in Heavily indebted poor countries in 2008 to that in 2011?
Provide a succinct answer. 0.96. What is the ratio of the Domestic credit (% of GDP) of Egypt, Arab Rep. in 2008 to that in 2011?
Ensure brevity in your answer.  1.37. What is the ratio of the Domestic credit (% of GDP) in Oman in 2008 to that in 2011?
Keep it short and to the point. 0.85. What is the ratio of the Domestic credit (% of GDP) in Thailand in 2008 to that in 2011?
Your response must be concise. 0.86. What is the ratio of the Domestic credit (% of GDP) in Heavily indebted poor countries in 2008 to that in 2012?
Provide a short and direct response. 0.9. What is the ratio of the Domestic credit (% of GDP) of Egypt, Arab Rep. in 2008 to that in 2012?
Make the answer very short. 1.47. What is the ratio of the Domestic credit (% of GDP) of Oman in 2008 to that in 2012?
Your response must be concise. 0.83. What is the ratio of the Domestic credit (% of GDP) of Thailand in 2008 to that in 2012?
Your answer should be very brief. 0.82. What is the ratio of the Domestic credit (% of GDP) of Heavily indebted poor countries in 2009 to that in 2010?
Your answer should be very brief. 1.01. What is the ratio of the Domestic credit (% of GDP) of Egypt, Arab Rep. in 2009 to that in 2010?
Provide a succinct answer. 1.09. What is the ratio of the Domestic credit (% of GDP) of Oman in 2009 to that in 2010?
Your answer should be compact. 1.1. What is the ratio of the Domestic credit (% of GDP) in Heavily indebted poor countries in 2009 to that in 2011?
Ensure brevity in your answer.  1.01. What is the ratio of the Domestic credit (% of GDP) of Egypt, Arab Rep. in 2009 to that in 2011?
Provide a succinct answer. 1.16. What is the ratio of the Domestic credit (% of GDP) in Oman in 2009 to that in 2011?
Your answer should be compact. 1.13. What is the ratio of the Domestic credit (% of GDP) of Thailand in 2009 to that in 2011?
Your answer should be very brief. 0.89. What is the ratio of the Domestic credit (% of GDP) of Heavily indebted poor countries in 2009 to that in 2012?
Provide a succinct answer. 0.94. What is the ratio of the Domestic credit (% of GDP) of Egypt, Arab Rep. in 2009 to that in 2012?
Offer a terse response. 1.24. What is the ratio of the Domestic credit (% of GDP) of Oman in 2009 to that in 2012?
Your answer should be very brief. 1.11. What is the ratio of the Domestic credit (% of GDP) of Thailand in 2009 to that in 2012?
Provide a succinct answer. 0.85. What is the ratio of the Domestic credit (% of GDP) in Egypt, Arab Rep. in 2010 to that in 2011?
Your answer should be very brief. 1.06. What is the ratio of the Domestic credit (% of GDP) in Oman in 2010 to that in 2011?
Provide a short and direct response. 1.03. What is the ratio of the Domestic credit (% of GDP) in Thailand in 2010 to that in 2011?
Your answer should be very brief. 0.89. What is the ratio of the Domestic credit (% of GDP) of Egypt, Arab Rep. in 2010 to that in 2012?
Keep it short and to the point. 1.14. What is the ratio of the Domestic credit (% of GDP) in Thailand in 2010 to that in 2012?
Your answer should be compact. 0.85. What is the ratio of the Domestic credit (% of GDP) in Heavily indebted poor countries in 2011 to that in 2012?
Make the answer very short. 0.93. What is the ratio of the Domestic credit (% of GDP) of Egypt, Arab Rep. in 2011 to that in 2012?
Give a very brief answer. 1.07. What is the ratio of the Domestic credit (% of GDP) of Oman in 2011 to that in 2012?
Provide a short and direct response. 0.98. What is the ratio of the Domestic credit (% of GDP) of Thailand in 2011 to that in 2012?
Offer a terse response. 0.95. What is the difference between the highest and the second highest Domestic credit (% of GDP) in Heavily indebted poor countries?
Offer a very short reply. 0.93. What is the difference between the highest and the second highest Domestic credit (% of GDP) in Egypt, Arab Rep.?
Provide a short and direct response. 2.72. What is the difference between the highest and the second highest Domestic credit (% of GDP) in Oman?
Provide a succinct answer. 4.34. What is the difference between the highest and the second highest Domestic credit (% of GDP) in Thailand?
Your answer should be compact. 4.91. What is the difference between the highest and the lowest Domestic credit (% of GDP) of Heavily indebted poor countries?
Your response must be concise. 2.18. What is the difference between the highest and the lowest Domestic credit (% of GDP) in Egypt, Arab Rep.?
Your answer should be very brief. 16.4. What is the difference between the highest and the lowest Domestic credit (% of GDP) in Oman?
Provide a succinct answer. 11.57. What is the difference between the highest and the lowest Domestic credit (% of GDP) in Thailand?
Provide a succinct answer. 20.17. 